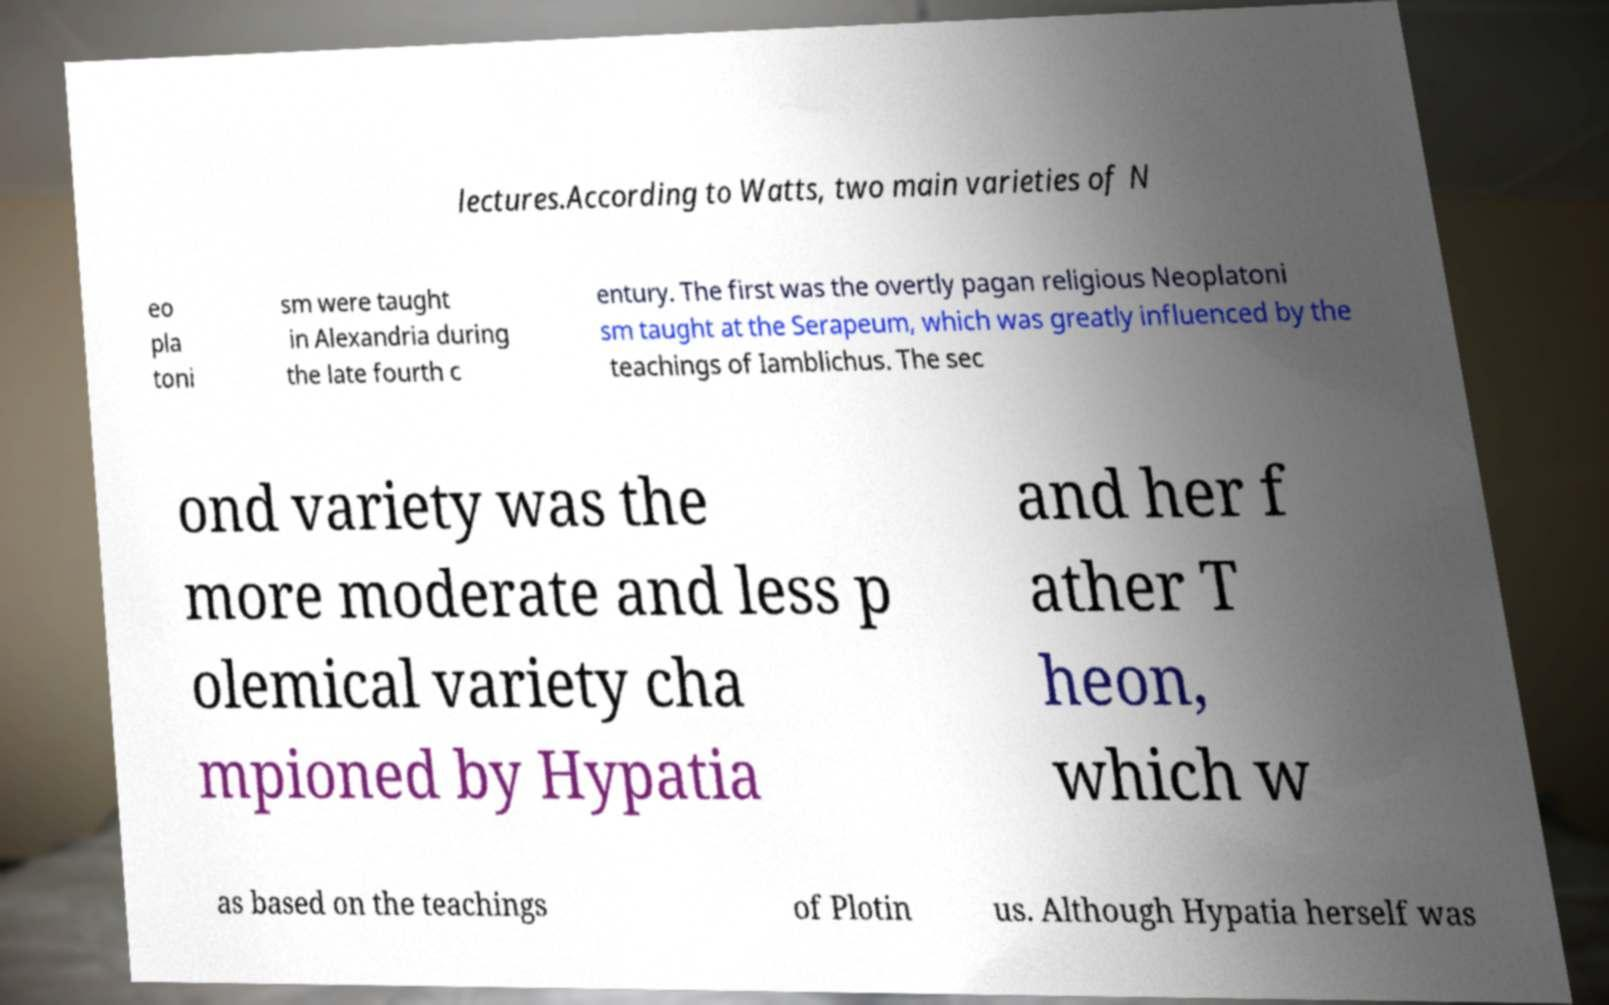There's text embedded in this image that I need extracted. Can you transcribe it verbatim? lectures.According to Watts, two main varieties of N eo pla toni sm were taught in Alexandria during the late fourth c entury. The first was the overtly pagan religious Neoplatoni sm taught at the Serapeum, which was greatly influenced by the teachings of Iamblichus. The sec ond variety was the more moderate and less p olemical variety cha mpioned by Hypatia and her f ather T heon, which w as based on the teachings of Plotin us. Although Hypatia herself was 